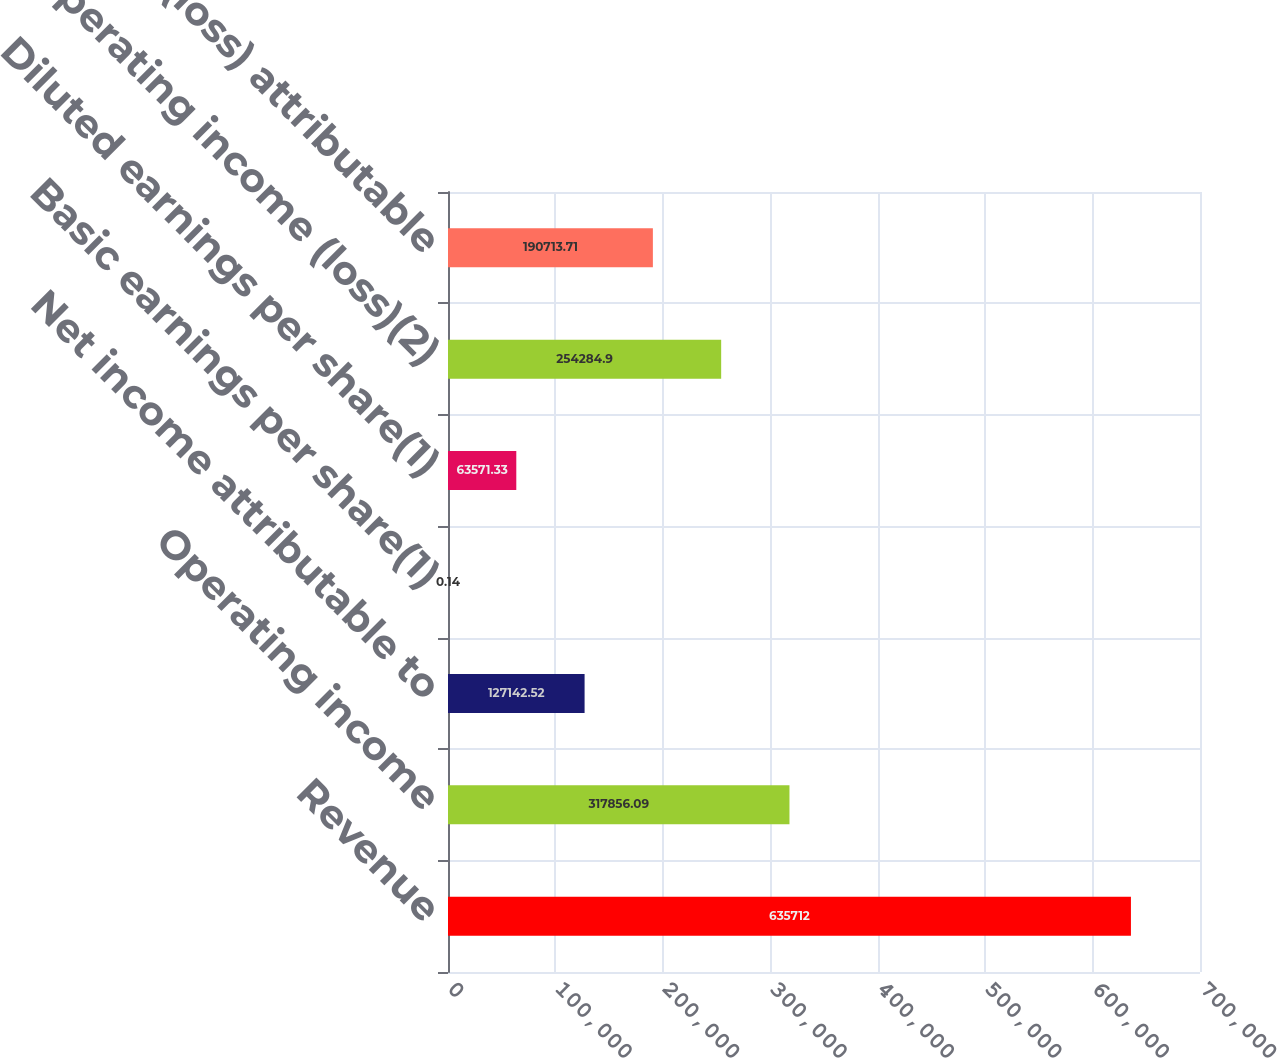Convert chart to OTSL. <chart><loc_0><loc_0><loc_500><loc_500><bar_chart><fcel>Revenue<fcel>Operating income<fcel>Net income attributable to<fcel>Basic earnings per share(1)<fcel>Diluted earnings per share(1)<fcel>Operating income (loss)(2)<fcel>Net income (loss) attributable<nl><fcel>635712<fcel>317856<fcel>127143<fcel>0.14<fcel>63571.3<fcel>254285<fcel>190714<nl></chart> 